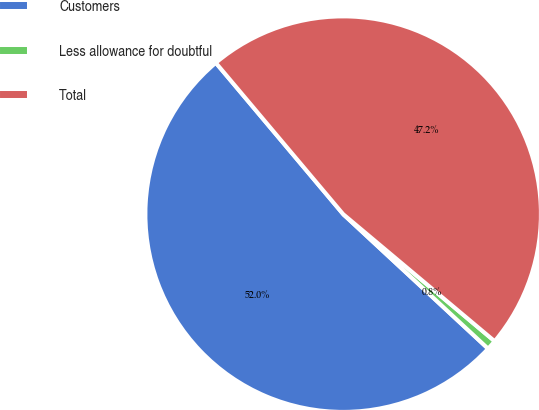<chart> <loc_0><loc_0><loc_500><loc_500><pie_chart><fcel>Customers<fcel>Less allowance for doubtful<fcel>Total<nl><fcel>51.96%<fcel>0.8%<fcel>47.24%<nl></chart> 